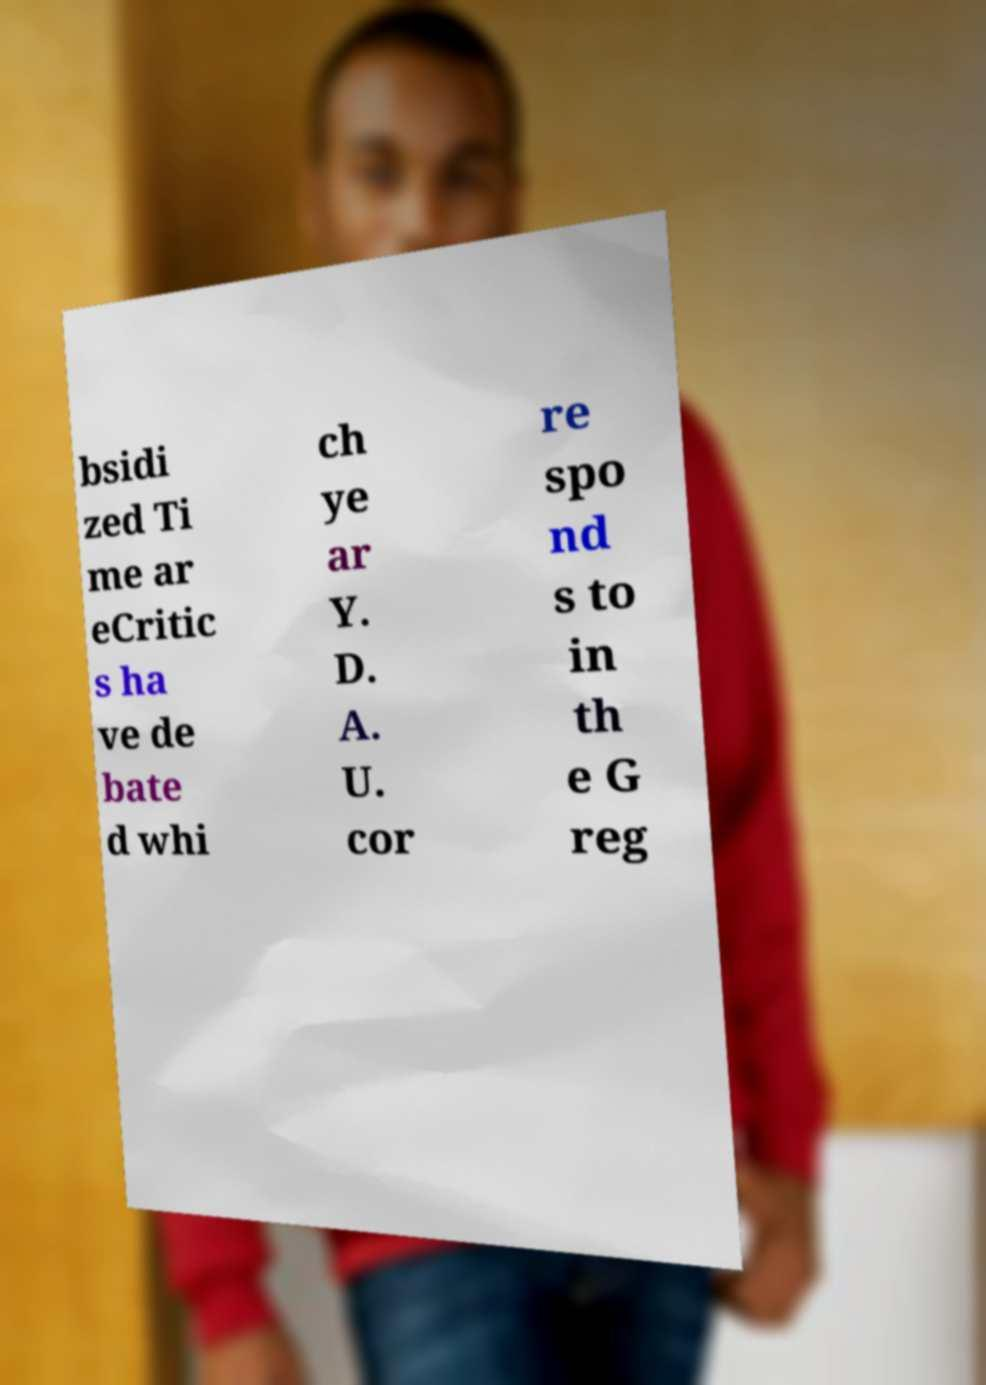What messages or text are displayed in this image? I need them in a readable, typed format. bsidi zed Ti me ar eCritic s ha ve de bate d whi ch ye ar Y. D. A. U. cor re spo nd s to in th e G reg 